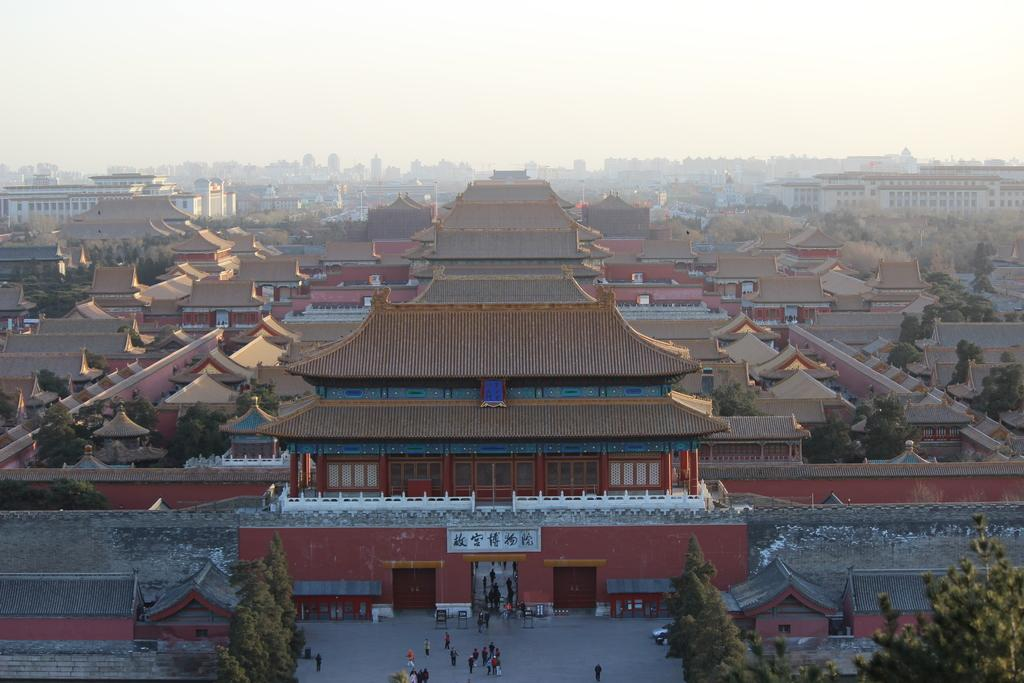What type of structures are present in the image? There are buildings with windows in the image. What other natural elements can be seen in the image? There are trees in the image. What can be used for transportation in the image? There is a road visible in the image. Who or what is present in the image? There are people in the image. What is visible in the background of the image? The sky is visible in the image. How many cattle are grazing in the square in the image? There are no cattle or squares present in the image. What type of expansion is taking place in the image? There is no indication of any expansion in the image. 